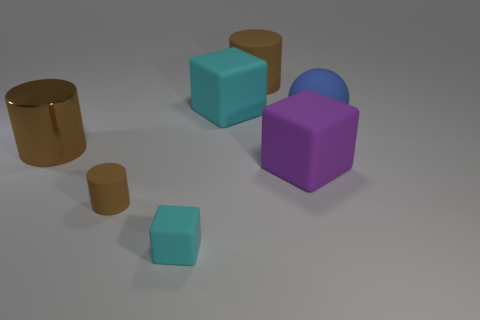Can you describe the scene and the arrangement of the various shapes? Certainly! The image presents a minimalist arrangement of geometric shapes on a plain surface under even lighting. There are two cubes, one large purple and one large cyan, alongside two cylinders, one small and one large, both in a gold-like color. Additionally, there is a smaller cyan cube that echoes the material and color of its larger counterpart. The shapes are dispersed with ample space between them, creating a sense of order and simplicity. 